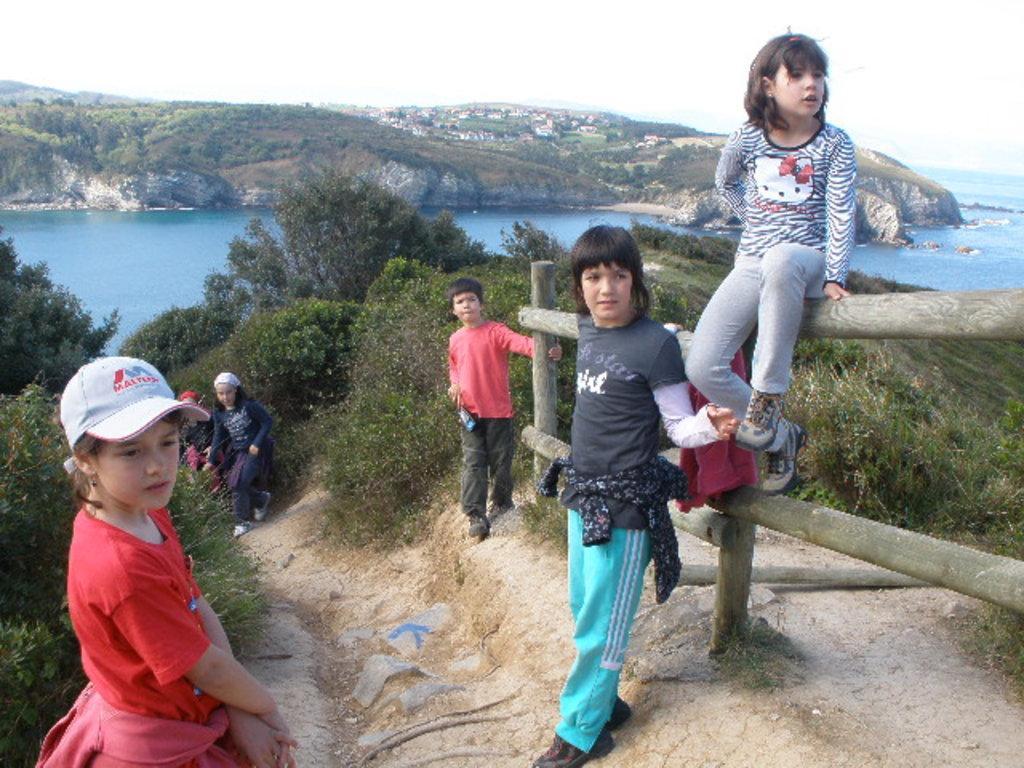Please provide a concise description of this image. In this image in the center there are Kids, standing and sitting and there are plants. In the center there is water and in the background there are buildings, trees ,,and the sky is cloudy. 